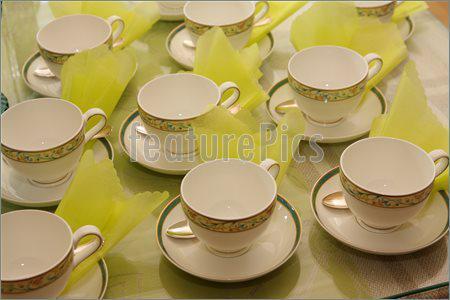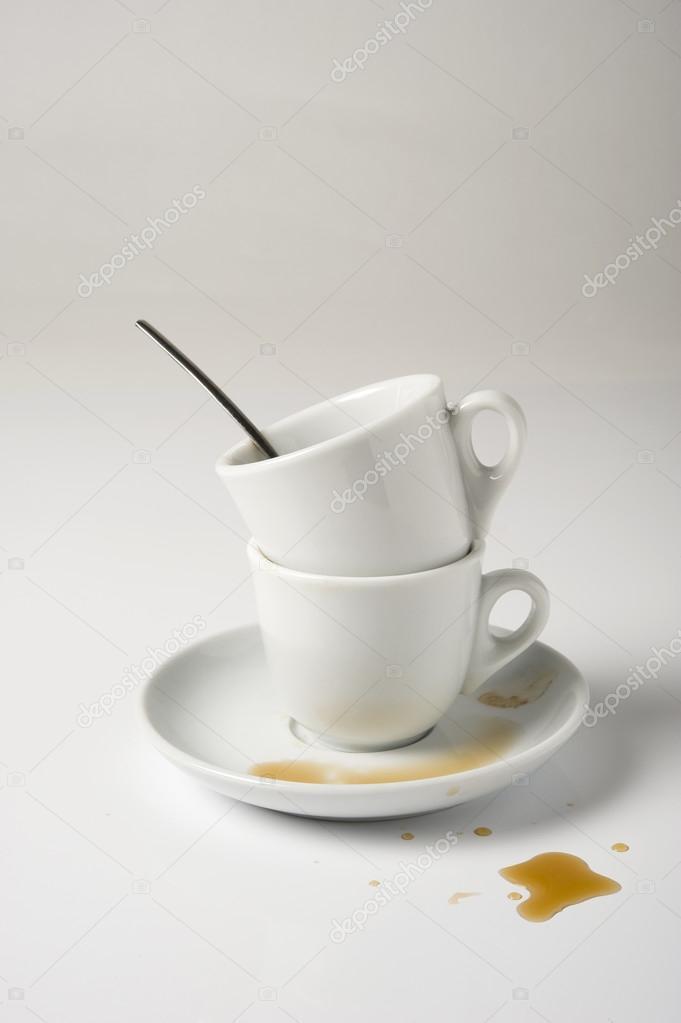The first image is the image on the left, the second image is the image on the right. Examine the images to the left and right. Is the description "In at least one image there is a dirty coffee cup with a spoon set on the cup plate." accurate? Answer yes or no. No. 